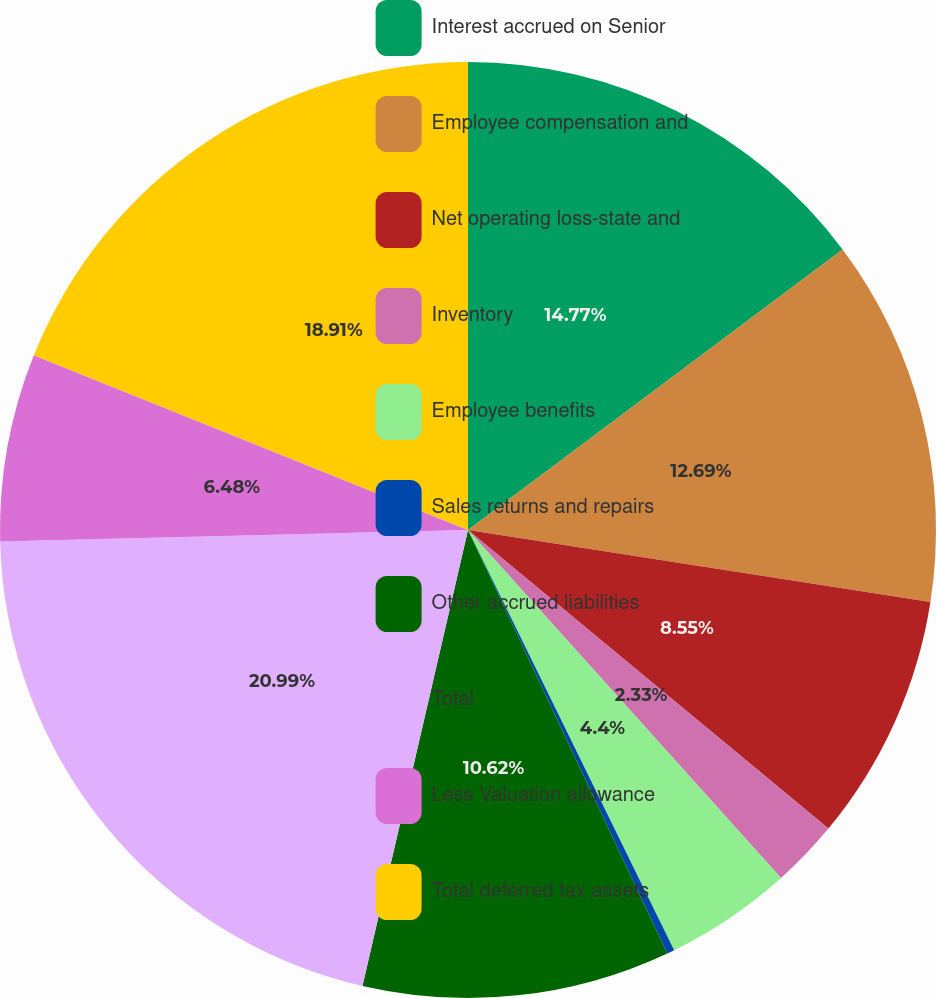Convert chart. <chart><loc_0><loc_0><loc_500><loc_500><pie_chart><fcel>Interest accrued on Senior<fcel>Employee compensation and<fcel>Net operating loss-state and<fcel>Inventory<fcel>Employee benefits<fcel>Sales returns and repairs<fcel>Other accrued liabilities<fcel>Total<fcel>Less Valuation allowance<fcel>Total deferred tax assets<nl><fcel>14.77%<fcel>12.69%<fcel>8.55%<fcel>2.33%<fcel>4.4%<fcel>0.26%<fcel>10.62%<fcel>20.99%<fcel>6.48%<fcel>18.91%<nl></chart> 